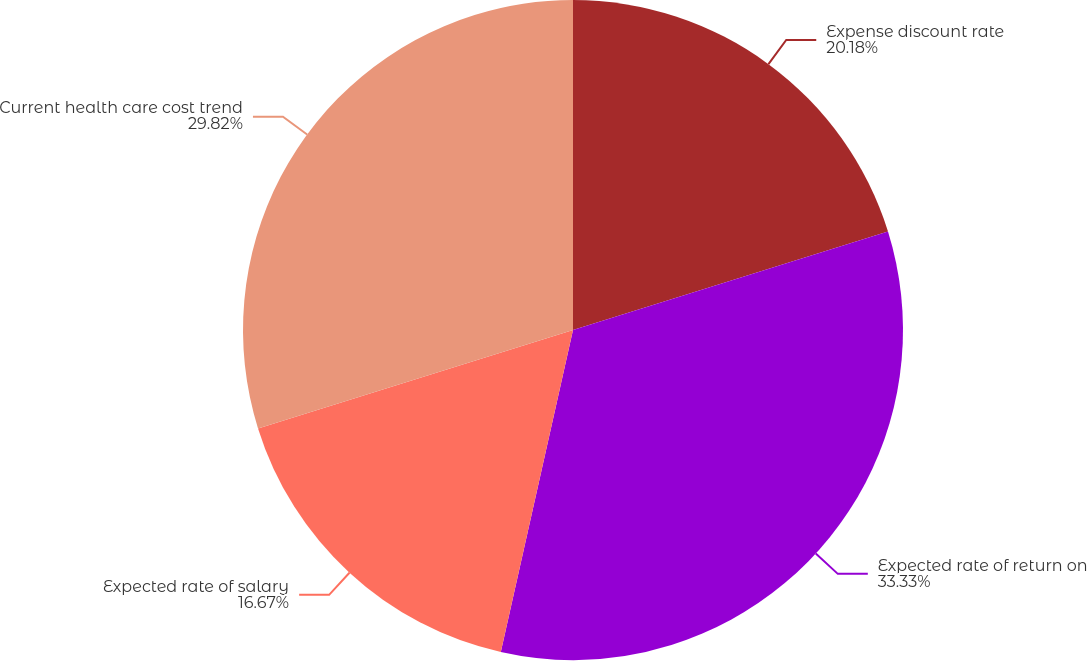Convert chart to OTSL. <chart><loc_0><loc_0><loc_500><loc_500><pie_chart><fcel>Expense discount rate<fcel>Expected rate of return on<fcel>Expected rate of salary<fcel>Current health care cost trend<nl><fcel>20.18%<fcel>33.33%<fcel>16.67%<fcel>29.82%<nl></chart> 